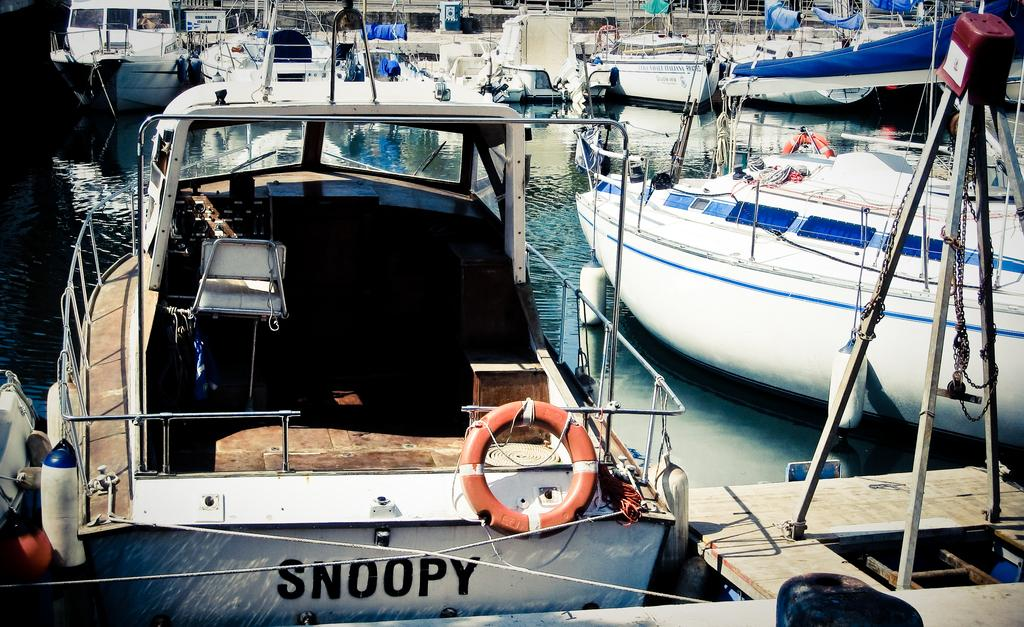What is the primary element visible in the image? There is water in the image. What is located above the water in the image? There are boats above the water in the image. What title does the person in the image hold? There is no person present in the image, so it is not possible to determine their title. 